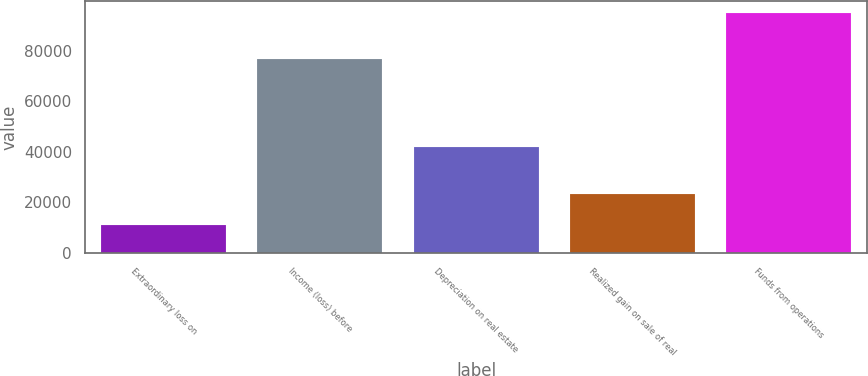<chart> <loc_0><loc_0><loc_500><loc_500><bar_chart><fcel>Extraordinary loss on<fcel>Income (loss) before<fcel>Depreciation on real estate<fcel>Realized gain on sale of real<fcel>Funds from operations<nl><fcel>11077<fcel>76783<fcel>41891<fcel>23514<fcel>95160<nl></chart> 